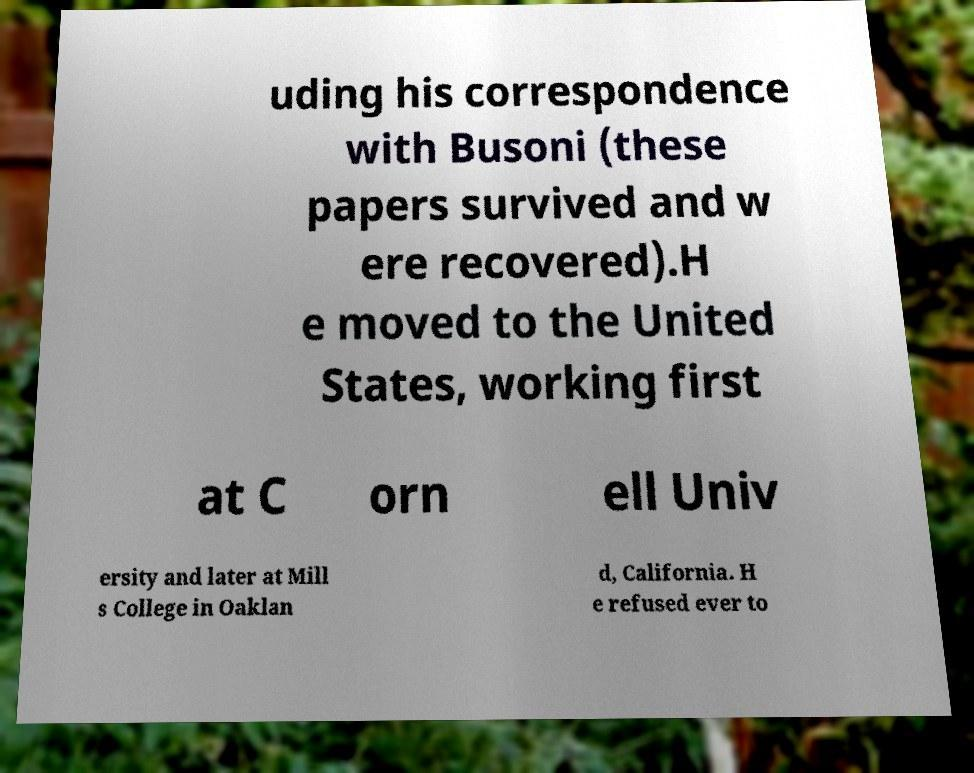Can you read and provide the text displayed in the image?This photo seems to have some interesting text. Can you extract and type it out for me? uding his correspondence with Busoni (these papers survived and w ere recovered).H e moved to the United States, working first at C orn ell Univ ersity and later at Mill s College in Oaklan d, California. H e refused ever to 